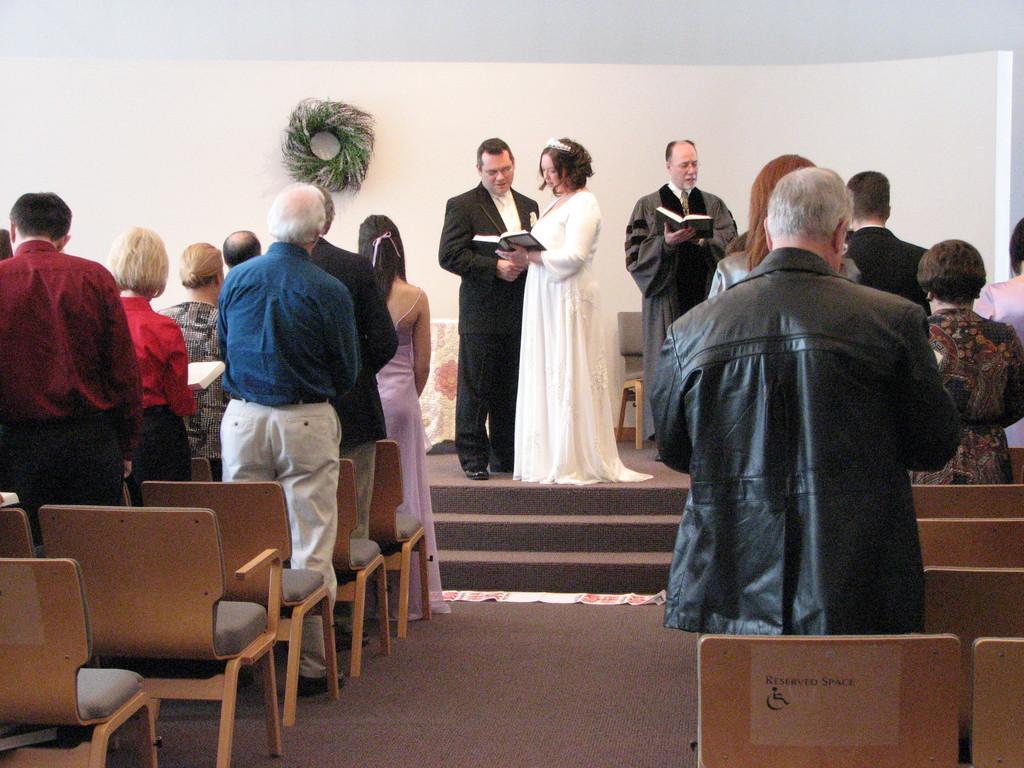In one or two sentences, can you explain what this image depicts? In this image we can see every person are standing. 